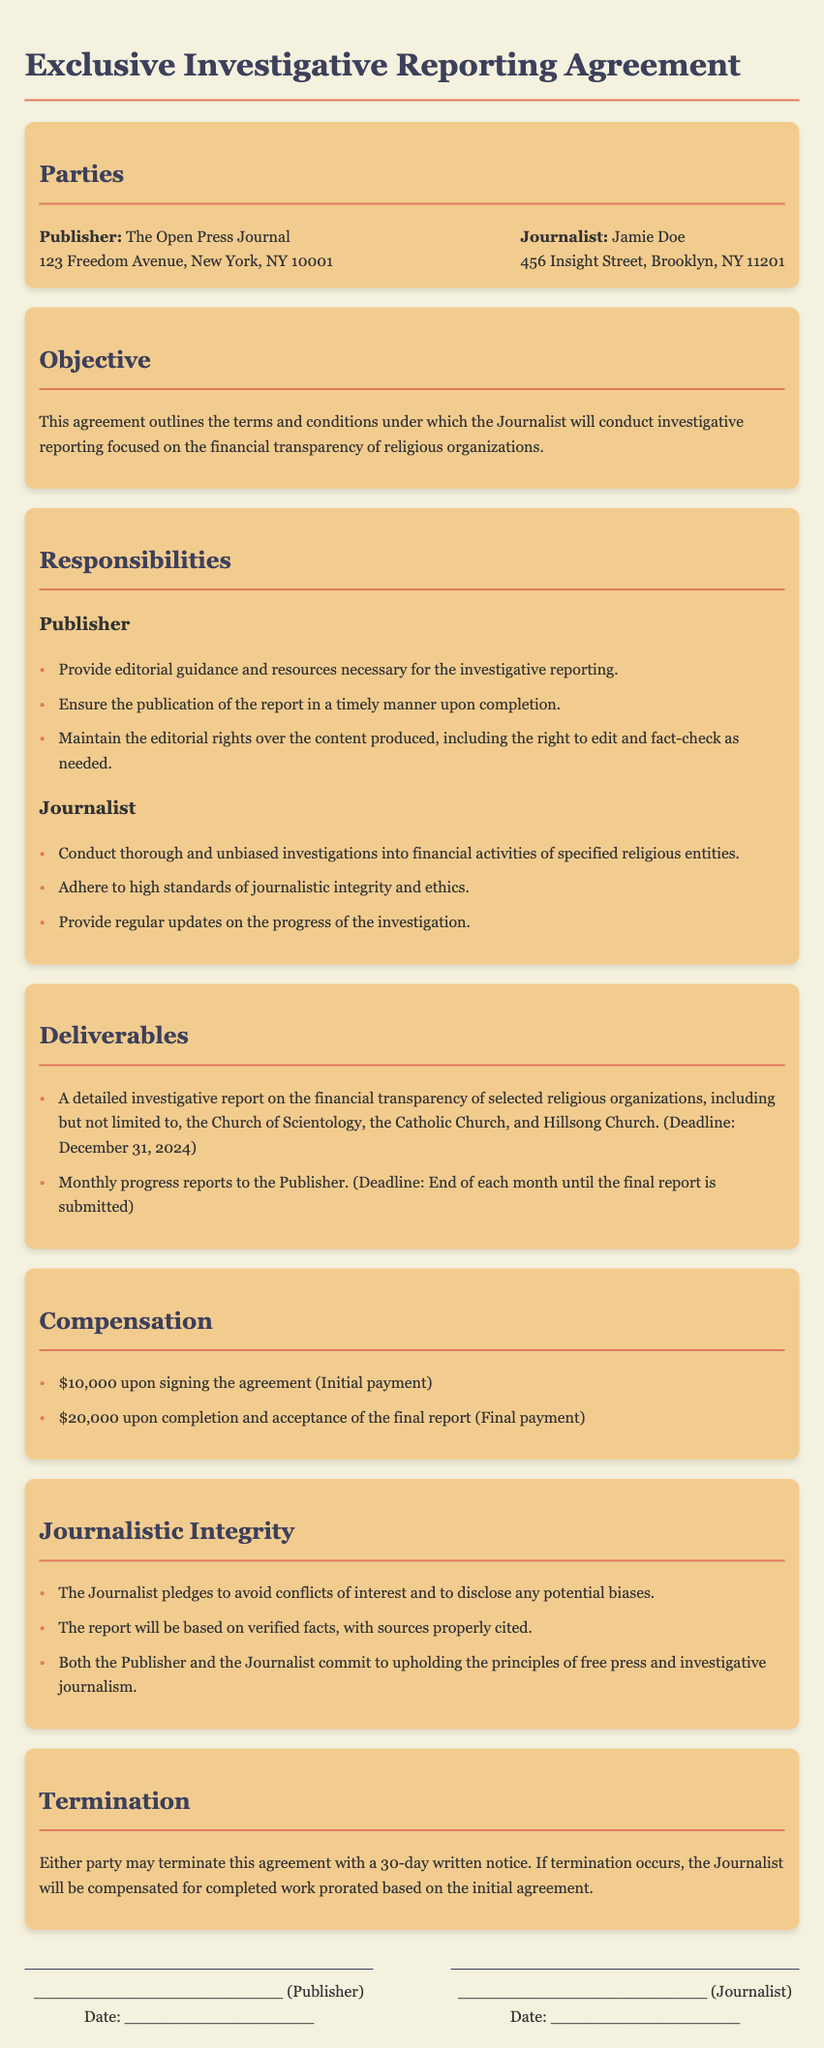What is the name of the Publisher? The name of the Publisher is specified in the document under the "Parties" section.
Answer: The Open Press Journal Who is the Journalist? The document identifies the Journalist in the "Parties" section.
Answer: Jamie Doe What is the initial payment amount? The amount for the initial payment is mentioned in the "Compensation" section.
Answer: $10,000 What is the final report deadline? The deadline for the final report is provided in the "Deliverables" section.
Answer: December 31, 2024 What are the monthly updates required? The document specifies a requirement for monthly updates in the "Deliverables" section.
Answer: Monthly progress reports What must the Journalist disclose? The obligations of the Journalist regarding disclosure are listed in the "Journalistic Integrity" section.
Answer: Any potential biases How long is the notice period for termination? The notice period for termination is outlined in the "Termination" section.
Answer: 30 days What is the total compensation upon completion? The total compensation upon completion is detailed in the "Compensation" section.
Answer: $20,000 What does the Publisher maintain over the content? The Publisher's rights over the content are mentioned in the "Responsibilities" section.
Answer: Editorial rights 